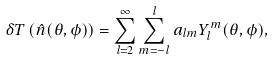Convert formula to latex. <formula><loc_0><loc_0><loc_500><loc_500>\delta T \left ( \hat { n } ( \theta , \phi ) \right ) = \sum _ { l = 2 } ^ { \infty } \sum _ { m = - l } ^ { l } a _ { l m } Y _ { l } ^ { m } ( \theta , \phi ) ,</formula> 